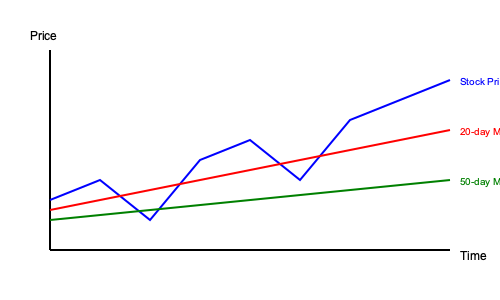Based on the stock price chart and moving averages shown, what trading signal is indicated at the rightmost point of the graph? To interpret the trading signal at the rightmost point of the graph, we need to analyze the relationship between the stock price and its moving averages:

1. Identify the lines:
   - Blue line: Stock price
   - Red line: 20-day moving average (MA)
   - Green line: 50-day moving average (MA)

2. Observe the positions of these lines at the rightmost point:
   - The stock price (blue) is above both the 20-day MA (red) and 50-day MA (green)
   - The 20-day MA is above the 50-day MA

3. Interpret the crossovers:
   - The stock price crossed above both MAs recently
   - The 20-day MA crossed above the 50-day MA

4. Analyze the trend:
   - All three lines are moving upward, indicating an uptrend

5. Apply technical analysis principles:
   - When the stock price is above both MAs, and the shorter-term MA (20-day) is above the longer-term MA (50-day), it's generally considered a bullish signal
   - The upward trend of all lines reinforces this bullish sentiment

6. Conclude the trading signal:
   - Given the stock price position relative to both MAs, the MA crossover, and the overall uptrend, the trading signal indicated is bullish or "buy"
Answer: Bullish (Buy) signal 